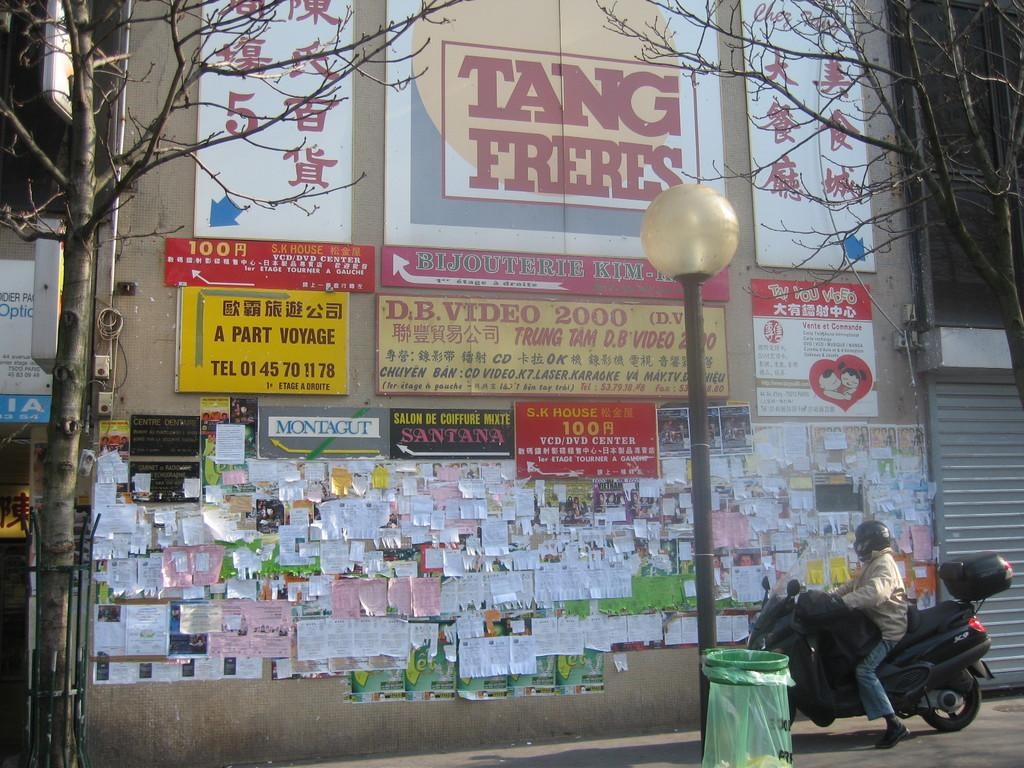What objects can be seen in the image? There are boards, stick bills on the wall, trees, a light pole, and a trash bin in the image. What activity is being performed by the person in the image? A person wearing a helmet is riding a bike on the road. What type of structure is present in the image? There are boards, which may indicate a construction site or a building under renovation. Can you tell me how many family members are present in the image? There is no family present in the image; only a person riding a bike is visible. What type of plants can be seen growing on the person's ear in the image? There is no person with plants growing on their ear in the image. 